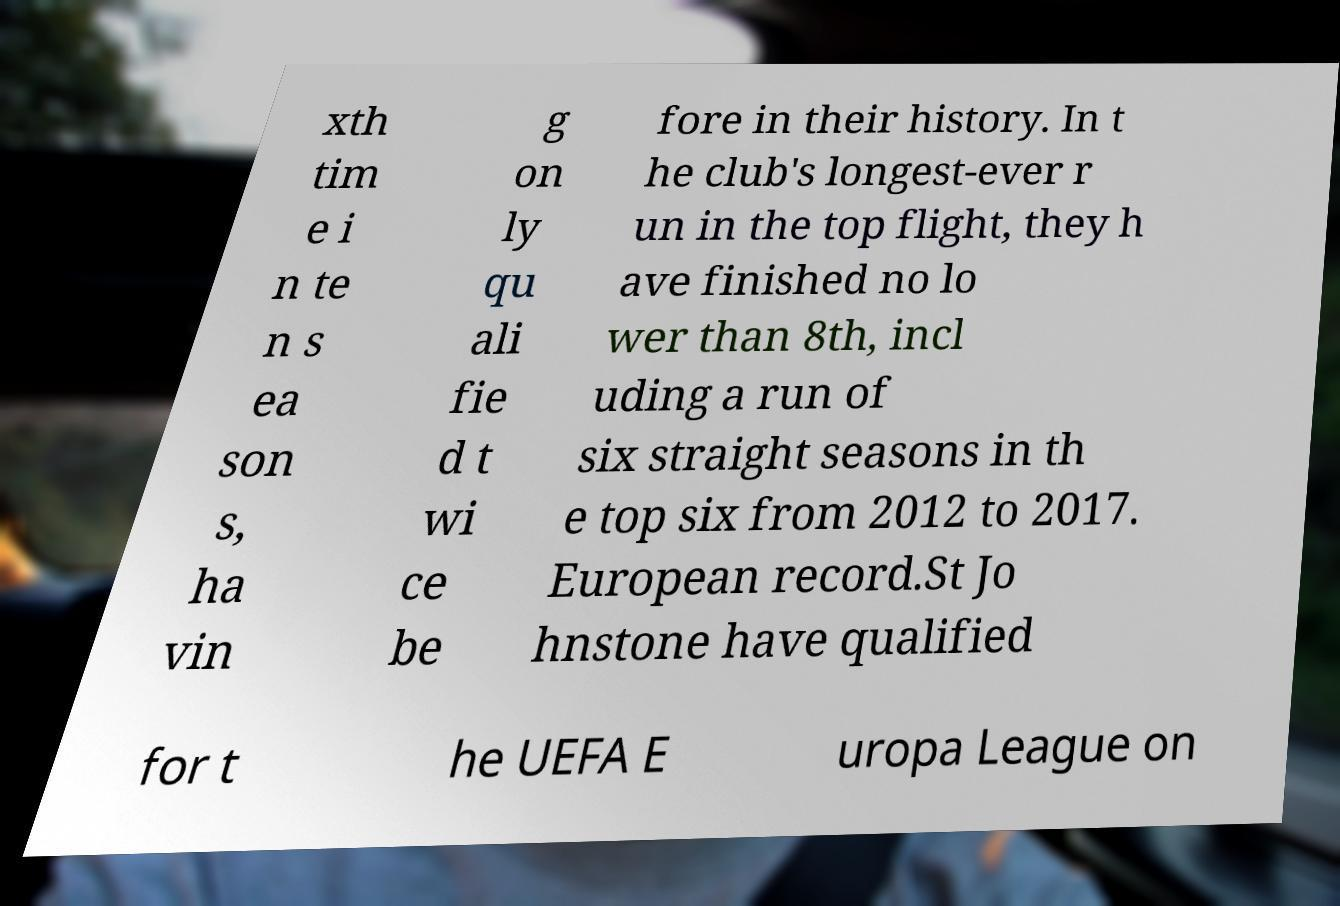Can you read and provide the text displayed in the image?This photo seems to have some interesting text. Can you extract and type it out for me? xth tim e i n te n s ea son s, ha vin g on ly qu ali fie d t wi ce be fore in their history. In t he club's longest-ever r un in the top flight, they h ave finished no lo wer than 8th, incl uding a run of six straight seasons in th e top six from 2012 to 2017. European record.St Jo hnstone have qualified for t he UEFA E uropa League on 